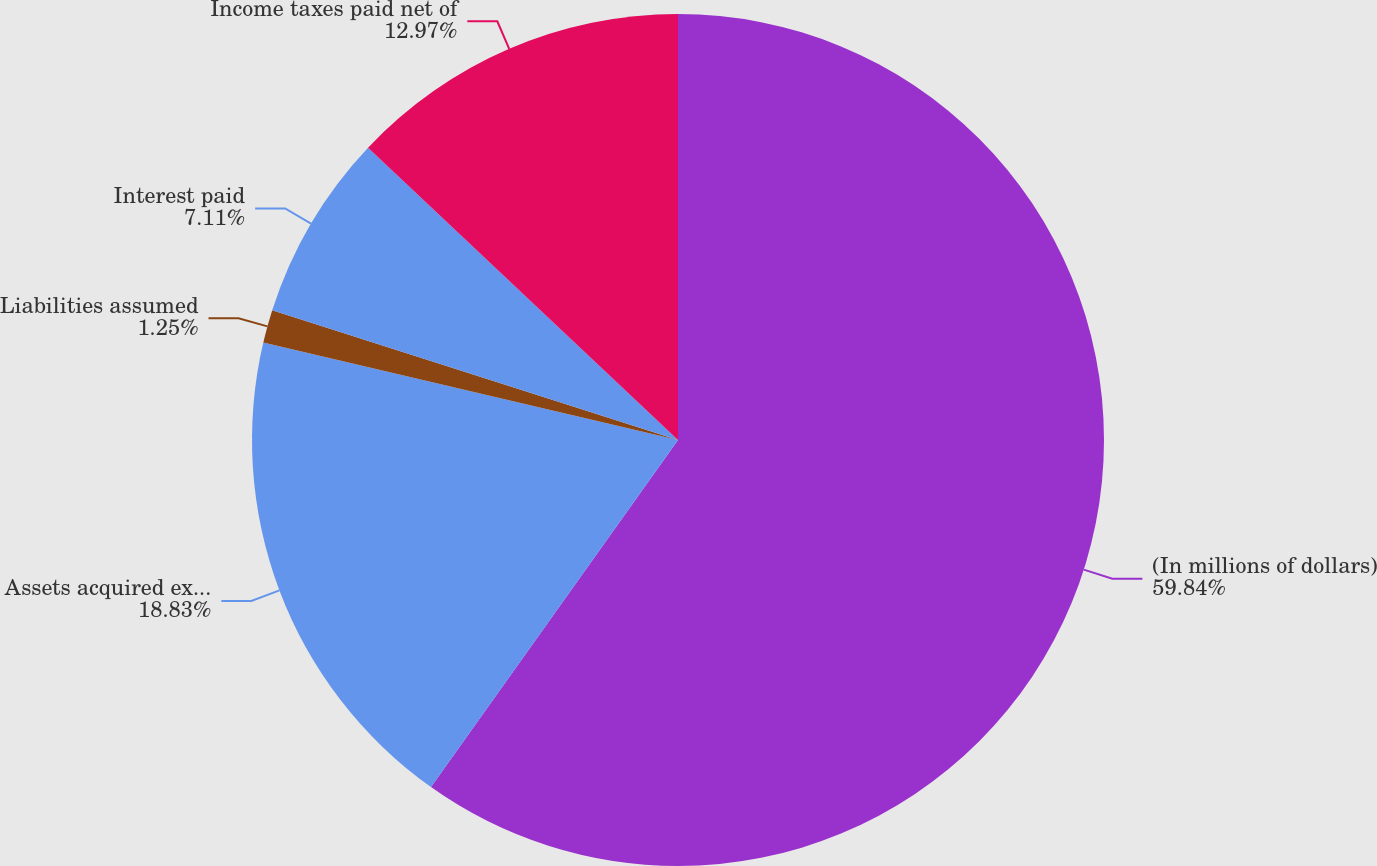Convert chart to OTSL. <chart><loc_0><loc_0><loc_500><loc_500><pie_chart><fcel>(In millions of dollars)<fcel>Assets acquired excluding cash<fcel>Liabilities assumed<fcel>Interest paid<fcel>Income taxes paid net of<nl><fcel>59.85%<fcel>18.83%<fcel>1.25%<fcel>7.11%<fcel>12.97%<nl></chart> 